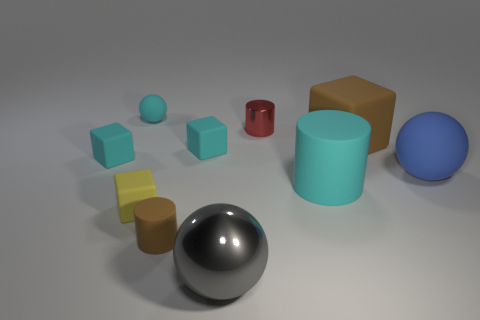What can you tell me about the various colors and shapes present in this image? The image depicts a variety of geometric shapes, including spheres, cubes, and cylinders, featuring an array of colors. The colors range from cool tones like cyan and blue to warm shades like yellow. The surfaces of these objects vary as well, with some having a matte finish that diffuses light, while others have glossy, reflective surfaces. 